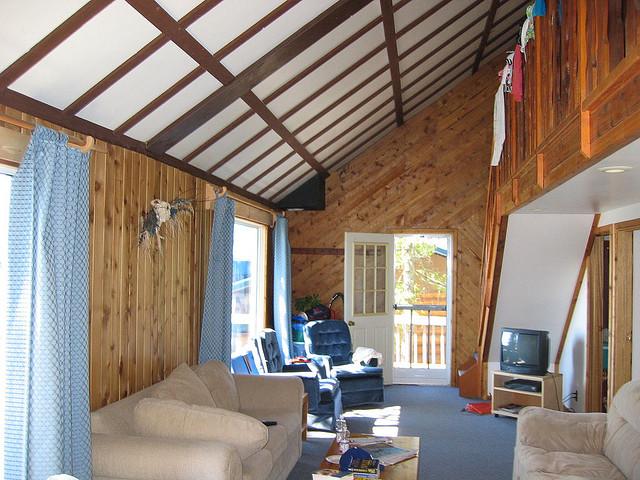What color are the curtains?
Quick response, please. Blue. Is this inside the house?
Quick response, please. Yes. Is the door open?
Quick response, please. Yes. 